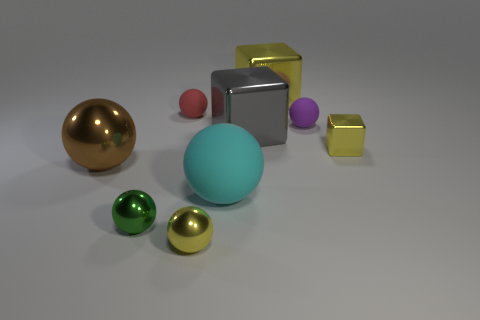How many small purple objects have the same material as the large yellow block?
Ensure brevity in your answer.  0. What material is the small yellow thing right of the matte thing right of the cyan sphere that is in front of the small yellow cube?
Make the answer very short. Metal. What color is the block behind the tiny rubber thing that is on the left side of the large yellow metallic object?
Your response must be concise. Yellow. There is another rubber thing that is the same size as the red matte object; what is its color?
Give a very brief answer. Purple. What number of big objects are either blue metallic blocks or red matte things?
Your answer should be compact. 0. Are there more large cubes that are in front of the tiny green metallic ball than small purple matte balls right of the cyan matte ball?
Offer a very short reply. No. What is the size of the other block that is the same color as the tiny cube?
Provide a short and direct response. Large. What number of other things are the same size as the gray shiny cube?
Make the answer very short. 3. Is the small yellow object in front of the brown metal sphere made of the same material as the small yellow cube?
Offer a very short reply. Yes. How many other objects are the same color as the big rubber sphere?
Offer a terse response. 0. 